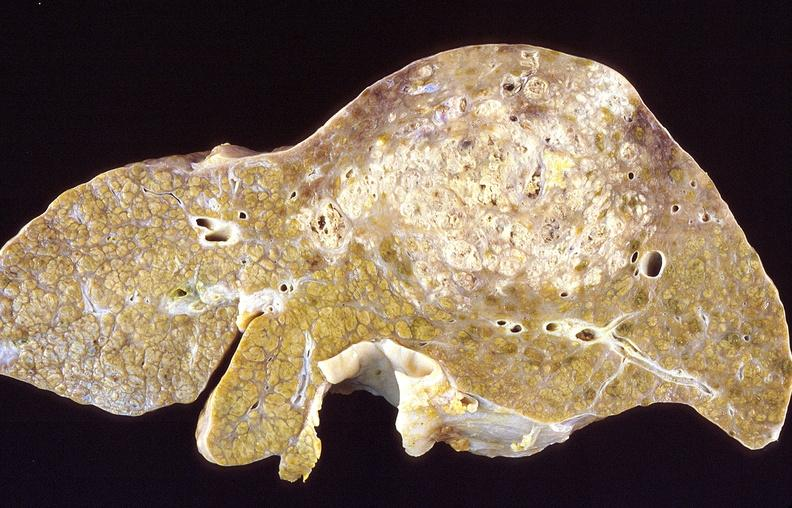s hepatobiliary present?
Answer the question using a single word or phrase. Yes 